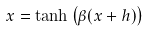<formula> <loc_0><loc_0><loc_500><loc_500>x = \tanh \left ( \beta ( x + h ) \right )</formula> 